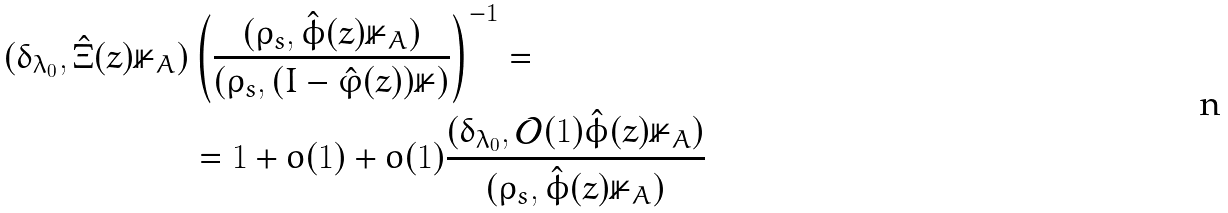Convert formula to latex. <formula><loc_0><loc_0><loc_500><loc_500>( \delta _ { \lambda _ { 0 } } , \hat { \Xi } ( z ) \mathbb { 1 } _ { A } ) & \left ( \frac { ( \rho _ { s } , \hat { \phi } ( z ) \mathbb { 1 } _ { A } ) } { ( \rho _ { s } , ( I - \hat { \varphi } ( z ) ) \mathbb { 1 } ) } \right ) ^ { - 1 } = \\ & = 1 + o ( 1 ) + o ( 1 ) \frac { ( \delta _ { \lambda _ { 0 } } , \mathcal { O } ( 1 ) \hat { \phi } ( z ) \mathbb { 1 } _ { A } ) } { ( \rho _ { s } , \hat { \phi } ( z ) \mathbb { 1 } _ { A } ) }</formula> 